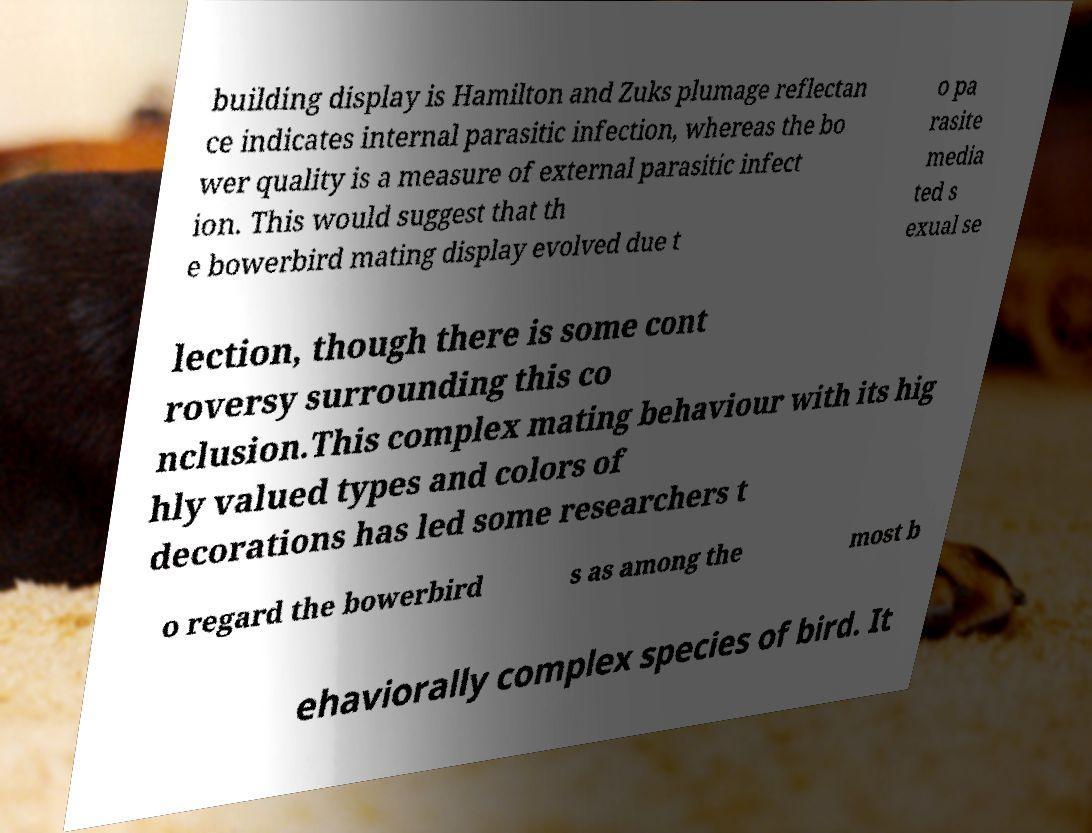Could you extract and type out the text from this image? building display is Hamilton and Zuks plumage reflectan ce indicates internal parasitic infection, whereas the bo wer quality is a measure of external parasitic infect ion. This would suggest that th e bowerbird mating display evolved due t o pa rasite media ted s exual se lection, though there is some cont roversy surrounding this co nclusion.This complex mating behaviour with its hig hly valued types and colors of decorations has led some researchers t o regard the bowerbird s as among the most b ehaviorally complex species of bird. It 